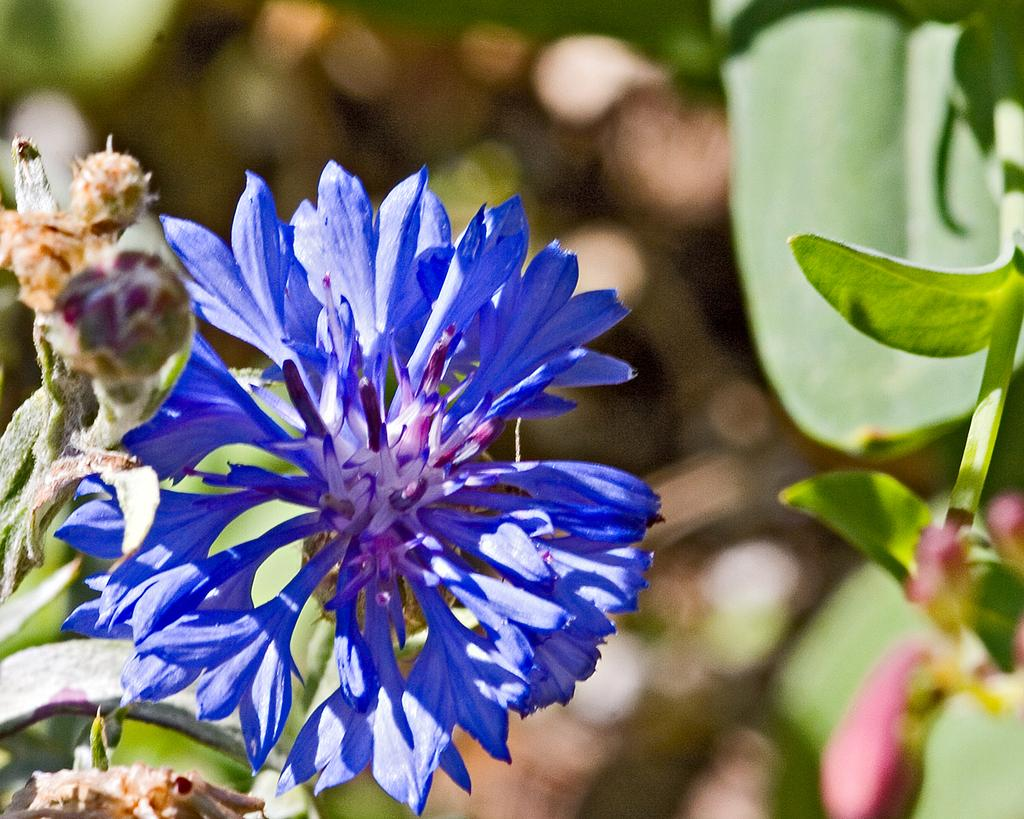What type of plant can be seen in the image? There is a plant with a flower, buds, and leaves in the image. Are there any other plants visible in the image? Yes, there is another plant with flowers and leaves on the right side of the image. Can you describe the background of the image? The background of the image is blurry. What type of wrench is being used to read the plant in the image? There is no wrench or reading activity present in the image; it features two plants with flowers and leaves. 